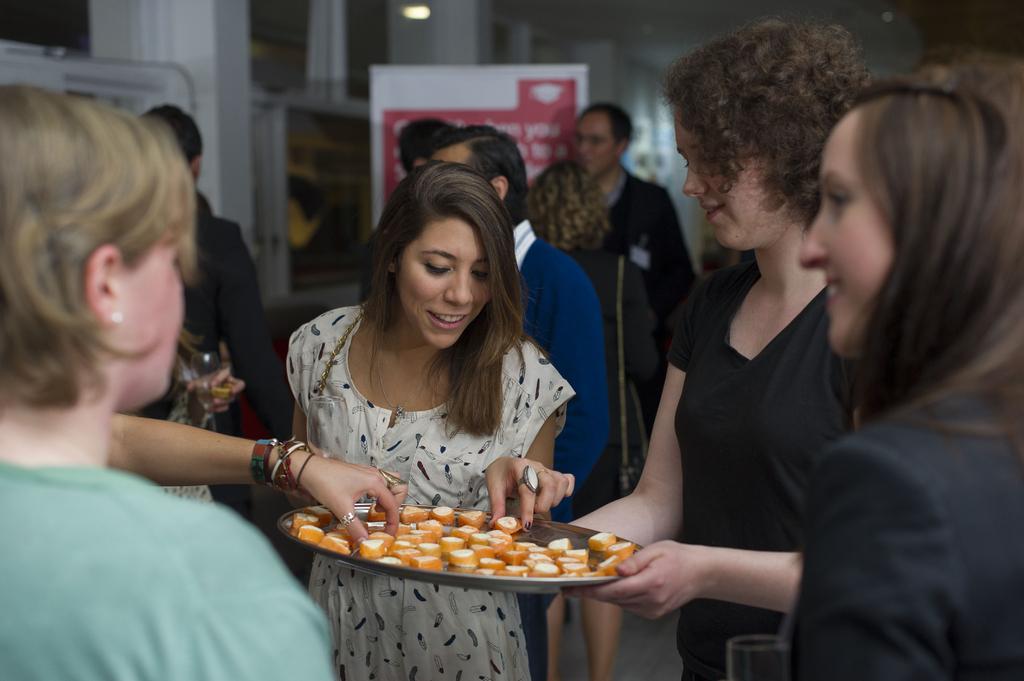Can you describe this image briefly? In the picture we can see some women standing and holding a plate full of food items in it and behind them, we can see some people are also standing, and behind them, we can see a banner and behind it we can see a wall with glass in it. 